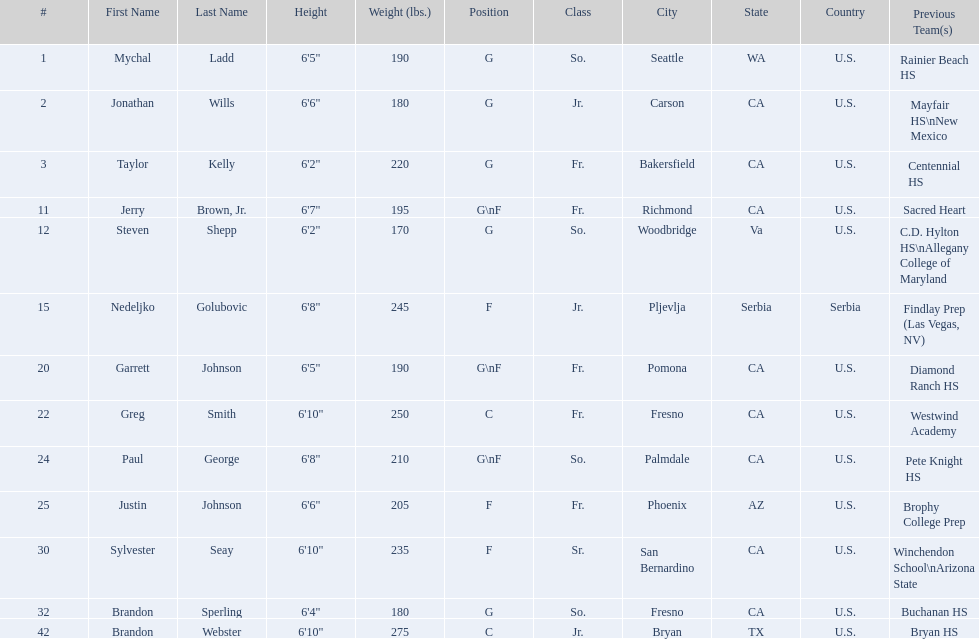Which player is taller, paul george or greg smith? Greg Smith. 